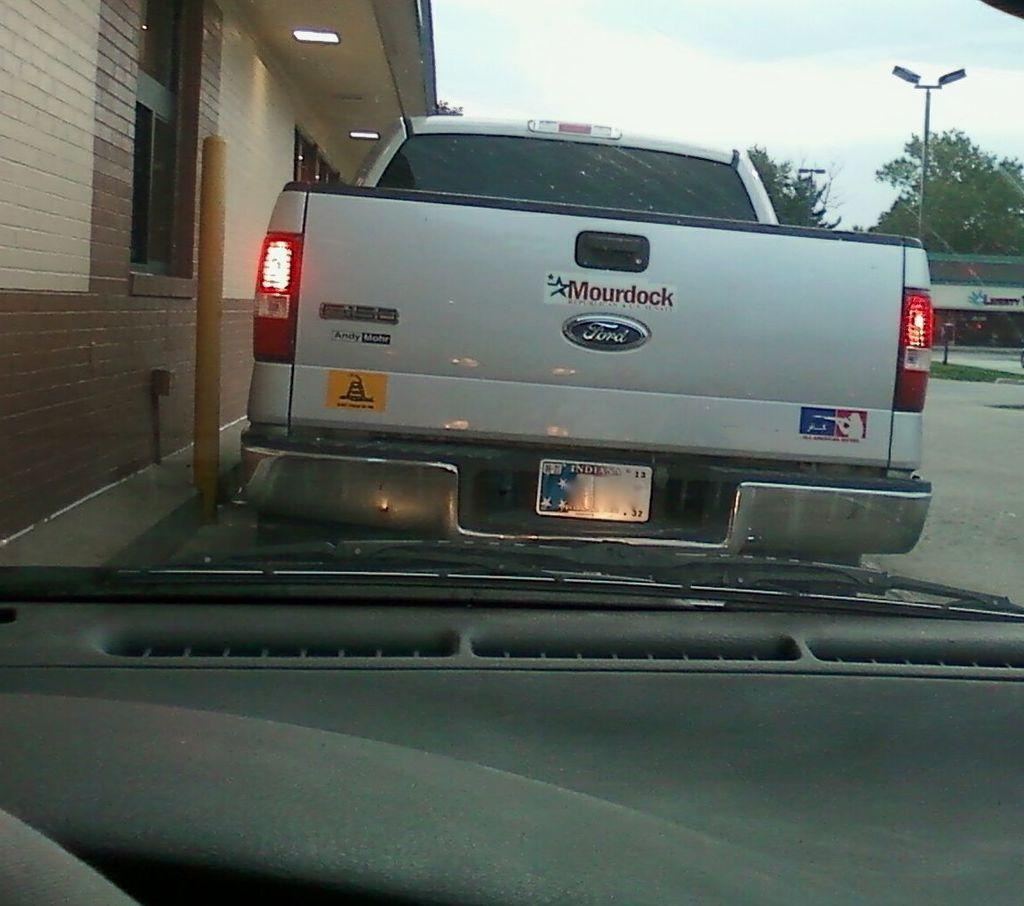Provide a one-sentence caption for the provided image. A ford tailgate with a big sticker that read Mourdock. 